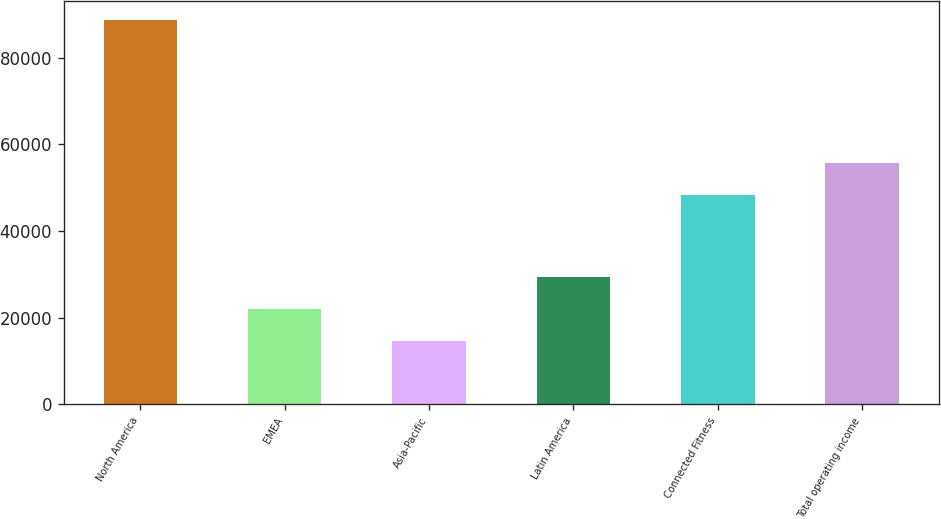Convert chart. <chart><loc_0><loc_0><loc_500><loc_500><bar_chart><fcel>North America<fcel>EMEA<fcel>Asia-Pacific<fcel>Latin America<fcel>Connected Fitness<fcel>Total operating income<nl><fcel>88614<fcel>21911.4<fcel>14500<fcel>29322.8<fcel>48237<fcel>55648.4<nl></chart> 